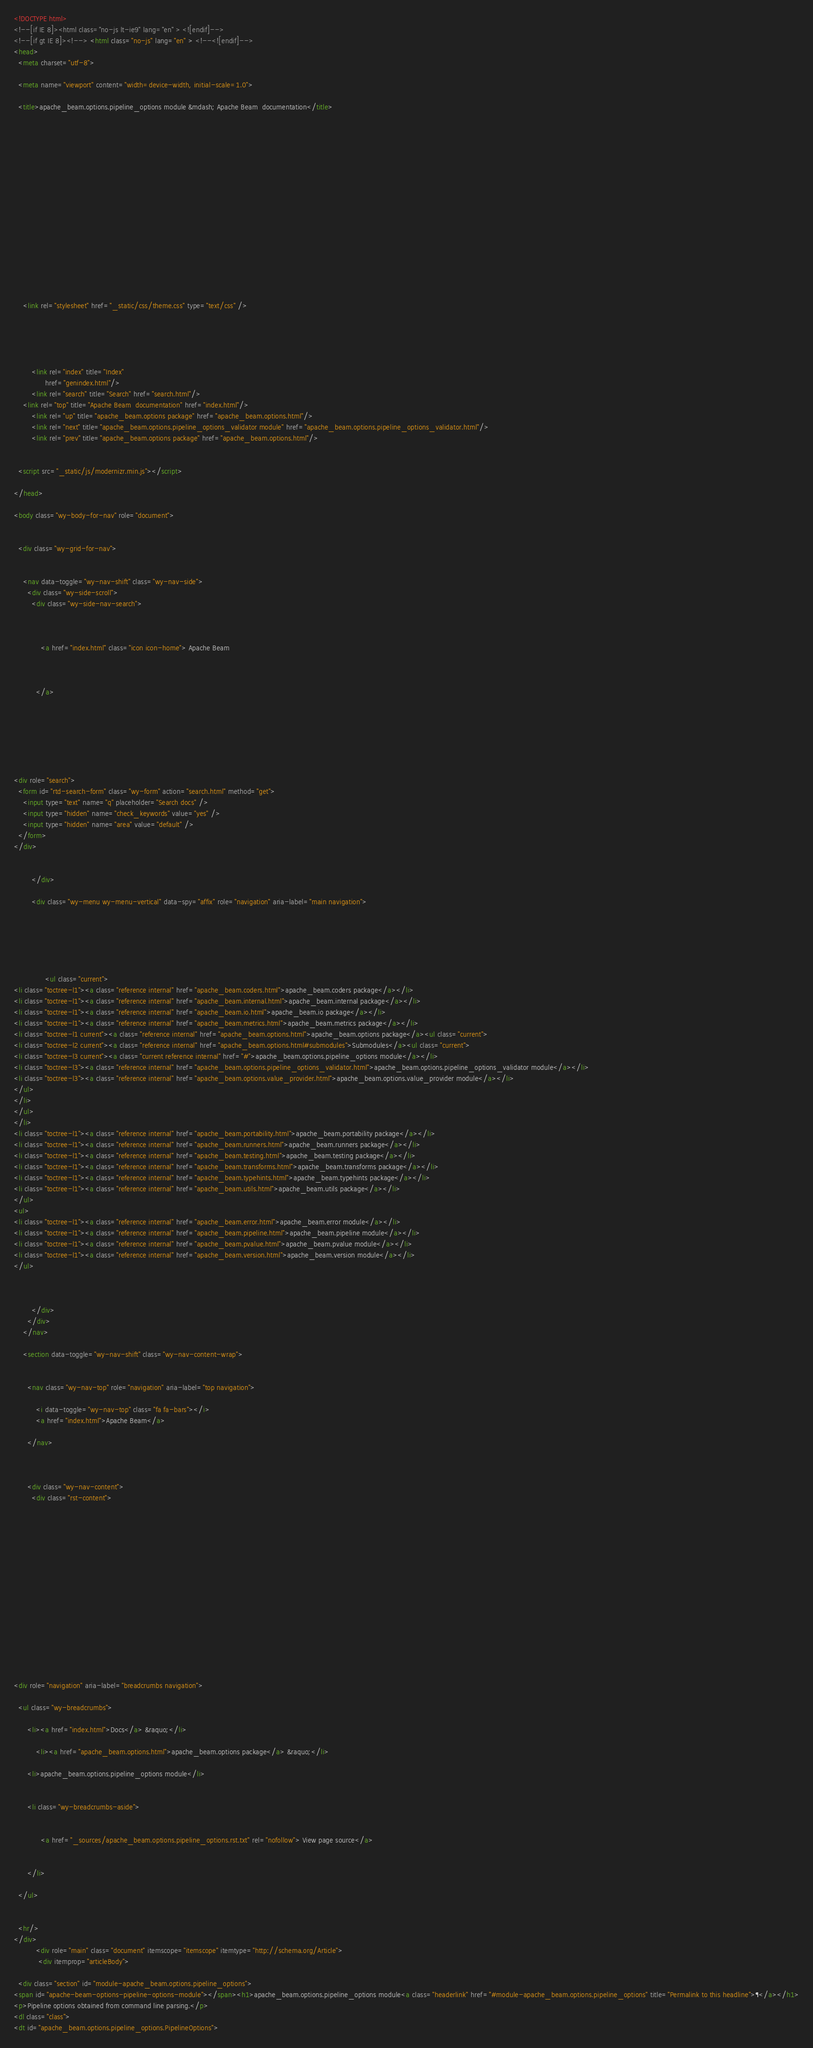<code> <loc_0><loc_0><loc_500><loc_500><_HTML_><!DOCTYPE html>
<!--[if IE 8]><html class="no-js lt-ie9" lang="en" > <![endif]-->
<!--[if gt IE 8]><!--> <html class="no-js" lang="en" > <!--<![endif]-->
<head>
  <meta charset="utf-8">
  
  <meta name="viewport" content="width=device-width, initial-scale=1.0">
  
  <title>apache_beam.options.pipeline_options module &mdash; Apache Beam  documentation</title>
  

  
  
  
  

  

  
  
    

  

  
  
    <link rel="stylesheet" href="_static/css/theme.css" type="text/css" />
  

  

  
        <link rel="index" title="Index"
              href="genindex.html"/>
        <link rel="search" title="Search" href="search.html"/>
    <link rel="top" title="Apache Beam  documentation" href="index.html"/>
        <link rel="up" title="apache_beam.options package" href="apache_beam.options.html"/>
        <link rel="next" title="apache_beam.options.pipeline_options_validator module" href="apache_beam.options.pipeline_options_validator.html"/>
        <link rel="prev" title="apache_beam.options package" href="apache_beam.options.html"/> 

  
  <script src="_static/js/modernizr.min.js"></script>

</head>

<body class="wy-body-for-nav" role="document">

   
  <div class="wy-grid-for-nav">

    
    <nav data-toggle="wy-nav-shift" class="wy-nav-side">
      <div class="wy-side-scroll">
        <div class="wy-side-nav-search">
          

          
            <a href="index.html" class="icon icon-home"> Apache Beam
          

          
          </a>

          
            
            
          

          
<div role="search">
  <form id="rtd-search-form" class="wy-form" action="search.html" method="get">
    <input type="text" name="q" placeholder="Search docs" />
    <input type="hidden" name="check_keywords" value="yes" />
    <input type="hidden" name="area" value="default" />
  </form>
</div>

          
        </div>

        <div class="wy-menu wy-menu-vertical" data-spy="affix" role="navigation" aria-label="main navigation">
          
            
            
              
            
            
              <ul class="current">
<li class="toctree-l1"><a class="reference internal" href="apache_beam.coders.html">apache_beam.coders package</a></li>
<li class="toctree-l1"><a class="reference internal" href="apache_beam.internal.html">apache_beam.internal package</a></li>
<li class="toctree-l1"><a class="reference internal" href="apache_beam.io.html">apache_beam.io package</a></li>
<li class="toctree-l1"><a class="reference internal" href="apache_beam.metrics.html">apache_beam.metrics package</a></li>
<li class="toctree-l1 current"><a class="reference internal" href="apache_beam.options.html">apache_beam.options package</a><ul class="current">
<li class="toctree-l2 current"><a class="reference internal" href="apache_beam.options.html#submodules">Submodules</a><ul class="current">
<li class="toctree-l3 current"><a class="current reference internal" href="#">apache_beam.options.pipeline_options module</a></li>
<li class="toctree-l3"><a class="reference internal" href="apache_beam.options.pipeline_options_validator.html">apache_beam.options.pipeline_options_validator module</a></li>
<li class="toctree-l3"><a class="reference internal" href="apache_beam.options.value_provider.html">apache_beam.options.value_provider module</a></li>
</ul>
</li>
</ul>
</li>
<li class="toctree-l1"><a class="reference internal" href="apache_beam.portability.html">apache_beam.portability package</a></li>
<li class="toctree-l1"><a class="reference internal" href="apache_beam.runners.html">apache_beam.runners package</a></li>
<li class="toctree-l1"><a class="reference internal" href="apache_beam.testing.html">apache_beam.testing package</a></li>
<li class="toctree-l1"><a class="reference internal" href="apache_beam.transforms.html">apache_beam.transforms package</a></li>
<li class="toctree-l1"><a class="reference internal" href="apache_beam.typehints.html">apache_beam.typehints package</a></li>
<li class="toctree-l1"><a class="reference internal" href="apache_beam.utils.html">apache_beam.utils package</a></li>
</ul>
<ul>
<li class="toctree-l1"><a class="reference internal" href="apache_beam.error.html">apache_beam.error module</a></li>
<li class="toctree-l1"><a class="reference internal" href="apache_beam.pipeline.html">apache_beam.pipeline module</a></li>
<li class="toctree-l1"><a class="reference internal" href="apache_beam.pvalue.html">apache_beam.pvalue module</a></li>
<li class="toctree-l1"><a class="reference internal" href="apache_beam.version.html">apache_beam.version module</a></li>
</ul>

            
          
        </div>
      </div>
    </nav>

    <section data-toggle="wy-nav-shift" class="wy-nav-content-wrap">

      
      <nav class="wy-nav-top" role="navigation" aria-label="top navigation">
        
          <i data-toggle="wy-nav-top" class="fa fa-bars"></i>
          <a href="index.html">Apache Beam</a>
        
      </nav>


      
      <div class="wy-nav-content">
        <div class="rst-content">
          















<div role="navigation" aria-label="breadcrumbs navigation">

  <ul class="wy-breadcrumbs">
    
      <li><a href="index.html">Docs</a> &raquo;</li>
        
          <li><a href="apache_beam.options.html">apache_beam.options package</a> &raquo;</li>
        
      <li>apache_beam.options.pipeline_options module</li>
    
    
      <li class="wy-breadcrumbs-aside">
        
            
            <a href="_sources/apache_beam.options.pipeline_options.rst.txt" rel="nofollow"> View page source</a>
          
        
      </li>
    
  </ul>

  
  <hr/>
</div>
          <div role="main" class="document" itemscope="itemscope" itemtype="http://schema.org/Article">
           <div itemprop="articleBody">
            
  <div class="section" id="module-apache_beam.options.pipeline_options">
<span id="apache-beam-options-pipeline-options-module"></span><h1>apache_beam.options.pipeline_options module<a class="headerlink" href="#module-apache_beam.options.pipeline_options" title="Permalink to this headline">¶</a></h1>
<p>Pipeline options obtained from command line parsing.</p>
<dl class="class">
<dt id="apache_beam.options.pipeline_options.PipelineOptions"></code> 